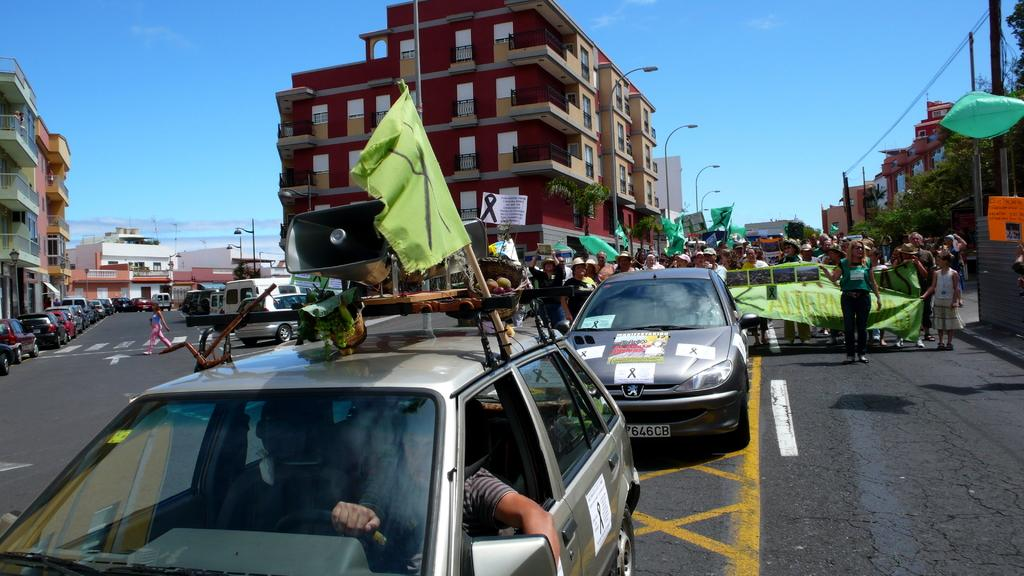What is the main feature in the center of the image? There is a road in the center of the image. What is happening on the road? There are vehicles on the road, and there are people holding a banner. What can be seen in the background of the image? There are buildings, a ski, and poles in the background of the image. How many dolls are sitting on the ski in the background of the image? There are no dolls present in the image, and therefore no dolls can be found sitting on the ski. 